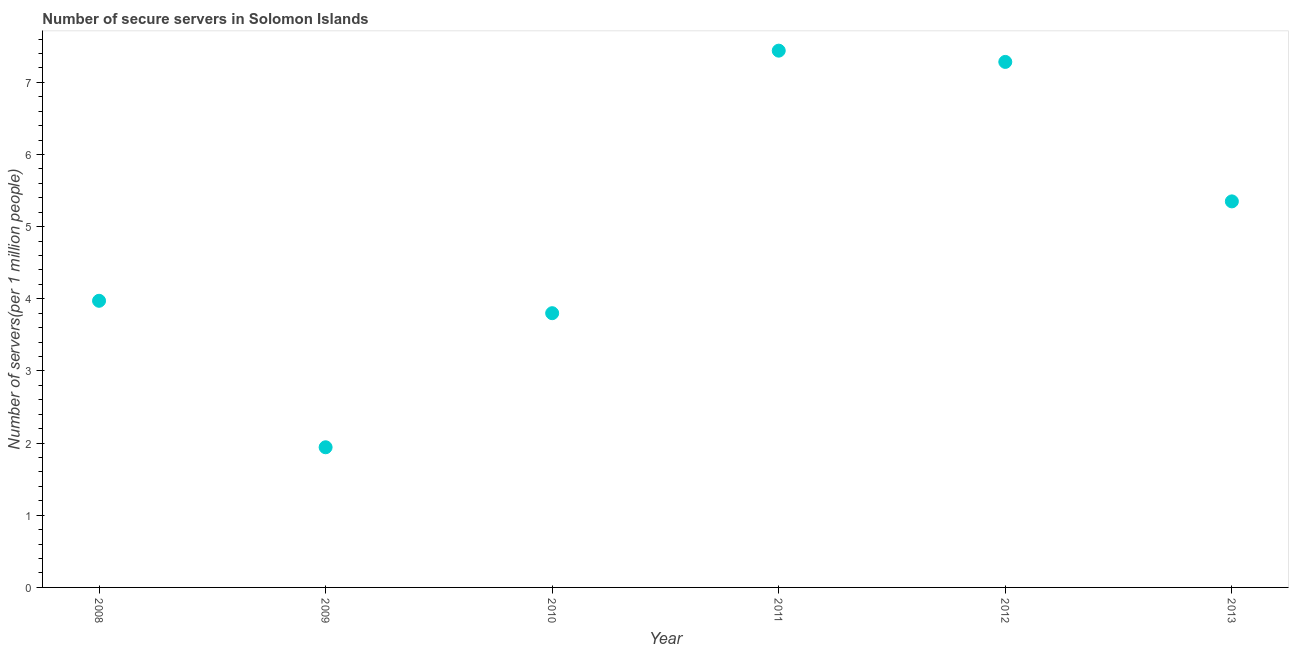What is the number of secure internet servers in 2011?
Provide a succinct answer. 7.44. Across all years, what is the maximum number of secure internet servers?
Provide a short and direct response. 7.44. Across all years, what is the minimum number of secure internet servers?
Make the answer very short. 1.94. In which year was the number of secure internet servers minimum?
Give a very brief answer. 2009. What is the sum of the number of secure internet servers?
Your answer should be very brief. 29.79. What is the difference between the number of secure internet servers in 2008 and 2013?
Keep it short and to the point. -1.38. What is the average number of secure internet servers per year?
Your answer should be compact. 4.97. What is the median number of secure internet servers?
Your response must be concise. 4.66. In how many years, is the number of secure internet servers greater than 0.2 ?
Make the answer very short. 6. What is the ratio of the number of secure internet servers in 2012 to that in 2013?
Provide a short and direct response. 1.36. What is the difference between the highest and the second highest number of secure internet servers?
Your response must be concise. 0.16. What is the difference between the highest and the lowest number of secure internet servers?
Offer a very short reply. 5.5. In how many years, is the number of secure internet servers greater than the average number of secure internet servers taken over all years?
Ensure brevity in your answer.  3. How many dotlines are there?
Offer a very short reply. 1. Does the graph contain grids?
Keep it short and to the point. No. What is the title of the graph?
Make the answer very short. Number of secure servers in Solomon Islands. What is the label or title of the Y-axis?
Make the answer very short. Number of servers(per 1 million people). What is the Number of servers(per 1 million people) in 2008?
Provide a succinct answer. 3.97. What is the Number of servers(per 1 million people) in 2009?
Offer a terse response. 1.94. What is the Number of servers(per 1 million people) in 2010?
Your answer should be very brief. 3.8. What is the Number of servers(per 1 million people) in 2011?
Make the answer very short. 7.44. What is the Number of servers(per 1 million people) in 2012?
Keep it short and to the point. 7.28. What is the Number of servers(per 1 million people) in 2013?
Make the answer very short. 5.35. What is the difference between the Number of servers(per 1 million people) in 2008 and 2009?
Provide a succinct answer. 2.03. What is the difference between the Number of servers(per 1 million people) in 2008 and 2010?
Provide a short and direct response. 0.17. What is the difference between the Number of servers(per 1 million people) in 2008 and 2011?
Keep it short and to the point. -3.47. What is the difference between the Number of servers(per 1 million people) in 2008 and 2012?
Make the answer very short. -3.31. What is the difference between the Number of servers(per 1 million people) in 2008 and 2013?
Your response must be concise. -1.38. What is the difference between the Number of servers(per 1 million people) in 2009 and 2010?
Provide a short and direct response. -1.86. What is the difference between the Number of servers(per 1 million people) in 2009 and 2011?
Make the answer very short. -5.5. What is the difference between the Number of servers(per 1 million people) in 2009 and 2012?
Keep it short and to the point. -5.34. What is the difference between the Number of servers(per 1 million people) in 2009 and 2013?
Provide a succinct answer. -3.41. What is the difference between the Number of servers(per 1 million people) in 2010 and 2011?
Your response must be concise. -3.64. What is the difference between the Number of servers(per 1 million people) in 2010 and 2012?
Offer a terse response. -3.48. What is the difference between the Number of servers(per 1 million people) in 2010 and 2013?
Provide a short and direct response. -1.55. What is the difference between the Number of servers(per 1 million people) in 2011 and 2012?
Ensure brevity in your answer.  0.16. What is the difference between the Number of servers(per 1 million people) in 2011 and 2013?
Provide a succinct answer. 2.09. What is the difference between the Number of servers(per 1 million people) in 2012 and 2013?
Provide a short and direct response. 1.93. What is the ratio of the Number of servers(per 1 million people) in 2008 to that in 2009?
Make the answer very short. 2.04. What is the ratio of the Number of servers(per 1 million people) in 2008 to that in 2010?
Your answer should be compact. 1.04. What is the ratio of the Number of servers(per 1 million people) in 2008 to that in 2011?
Give a very brief answer. 0.53. What is the ratio of the Number of servers(per 1 million people) in 2008 to that in 2012?
Ensure brevity in your answer.  0.55. What is the ratio of the Number of servers(per 1 million people) in 2008 to that in 2013?
Ensure brevity in your answer.  0.74. What is the ratio of the Number of servers(per 1 million people) in 2009 to that in 2010?
Ensure brevity in your answer.  0.51. What is the ratio of the Number of servers(per 1 million people) in 2009 to that in 2011?
Ensure brevity in your answer.  0.26. What is the ratio of the Number of servers(per 1 million people) in 2009 to that in 2012?
Make the answer very short. 0.27. What is the ratio of the Number of servers(per 1 million people) in 2009 to that in 2013?
Offer a terse response. 0.36. What is the ratio of the Number of servers(per 1 million people) in 2010 to that in 2011?
Your response must be concise. 0.51. What is the ratio of the Number of servers(per 1 million people) in 2010 to that in 2012?
Your response must be concise. 0.52. What is the ratio of the Number of servers(per 1 million people) in 2010 to that in 2013?
Offer a very short reply. 0.71. What is the ratio of the Number of servers(per 1 million people) in 2011 to that in 2012?
Give a very brief answer. 1.02. What is the ratio of the Number of servers(per 1 million people) in 2011 to that in 2013?
Your answer should be very brief. 1.39. What is the ratio of the Number of servers(per 1 million people) in 2012 to that in 2013?
Your answer should be compact. 1.36. 